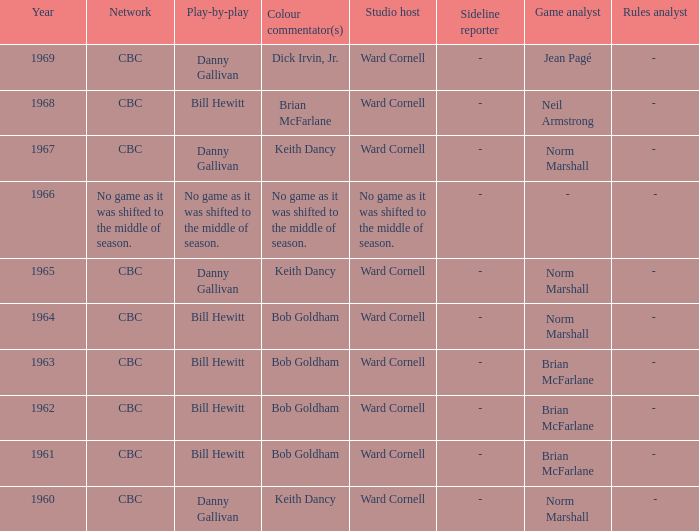Who gave the play by play commentary with studio host Ward Cornell? Danny Gallivan, Bill Hewitt, Danny Gallivan, Danny Gallivan, Bill Hewitt, Bill Hewitt, Bill Hewitt, Bill Hewitt, Danny Gallivan. 